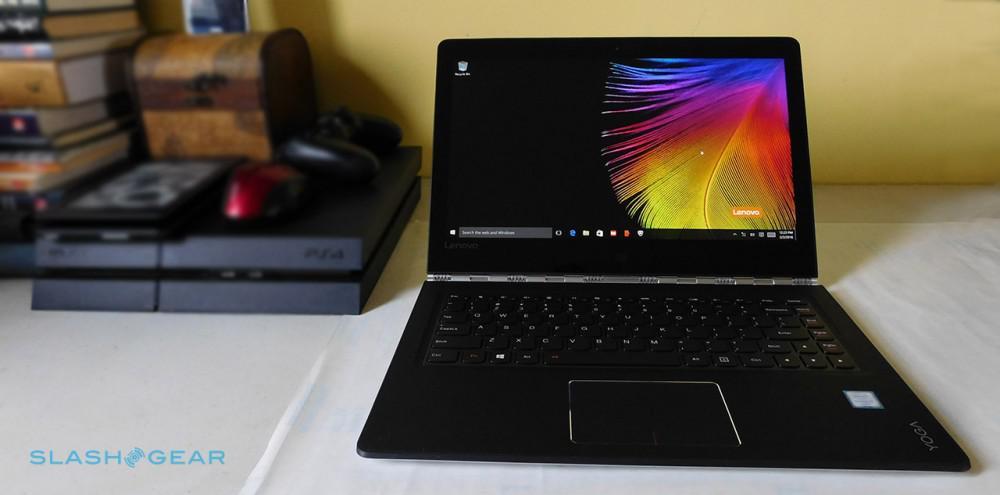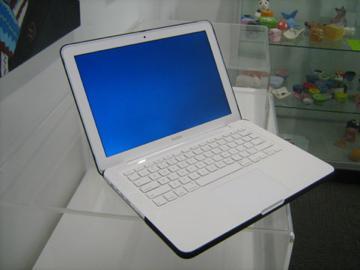The first image is the image on the left, the second image is the image on the right. For the images shown, is this caption "One image contains twice as many laptops as the other image, and the other image features a rightward-facing laptop with a blue-and-green wave on its screen." true? Answer yes or no. No. The first image is the image on the left, the second image is the image on the right. Examine the images to the left and right. Is the description "The left and right image contains the same number of laptops." accurate? Answer yes or no. Yes. 